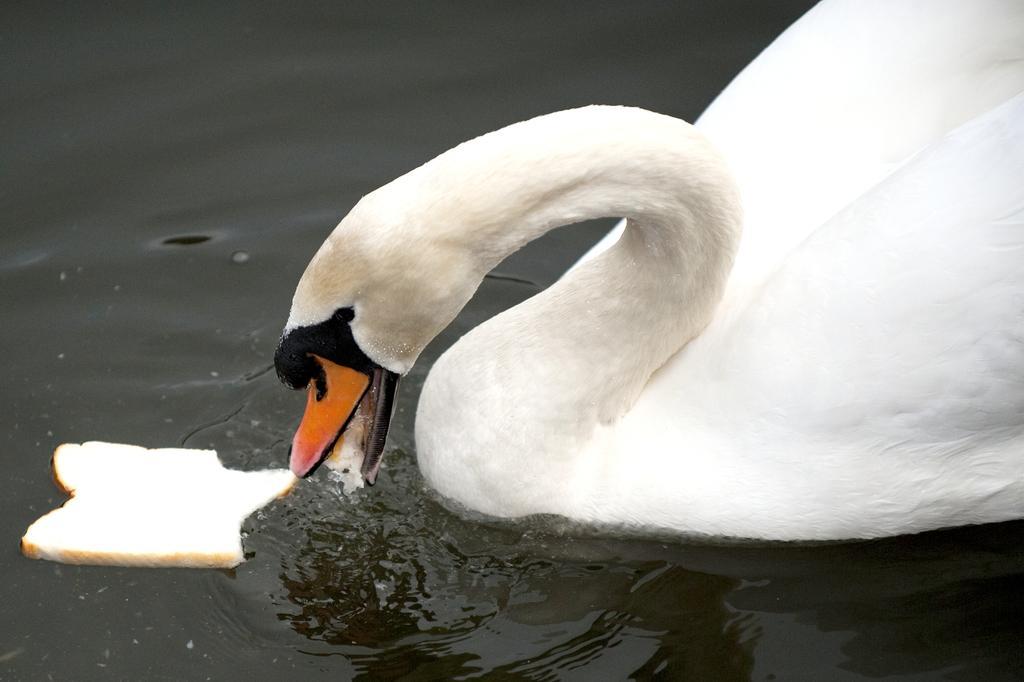Could you give a brief overview of what you see in this image? In the image I can see a swan in the water and also I can see a piece of bread which is in front of it. 